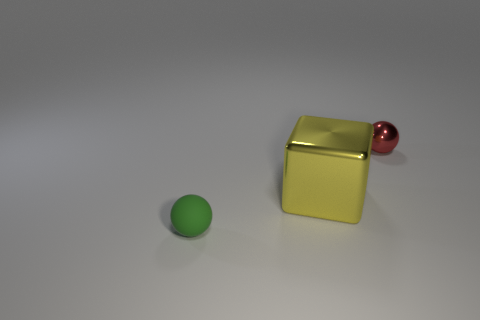The object that is both to the right of the small green rubber thing and to the left of the small red metal sphere is made of what material?
Keep it short and to the point. Metal. What number of tiny rubber objects are the same shape as the large yellow shiny object?
Make the answer very short. 0. There is a tiny thing that is on the left side of the small red thing; what is it made of?
Offer a very short reply. Rubber. Is the number of small red metal balls on the left side of the green matte sphere less than the number of brown objects?
Provide a short and direct response. No. Does the green matte object have the same shape as the yellow metallic thing?
Provide a succinct answer. No. Is there anything else that is the same shape as the large yellow metallic thing?
Ensure brevity in your answer.  No. Are any big cyan shiny spheres visible?
Your answer should be very brief. No. Is the shape of the green thing the same as the small thing that is on the right side of the green object?
Your answer should be very brief. Yes. The tiny sphere on the left side of the small thing on the right side of the tiny green thing is made of what material?
Make the answer very short. Rubber. The tiny matte object is what color?
Provide a short and direct response. Green. 